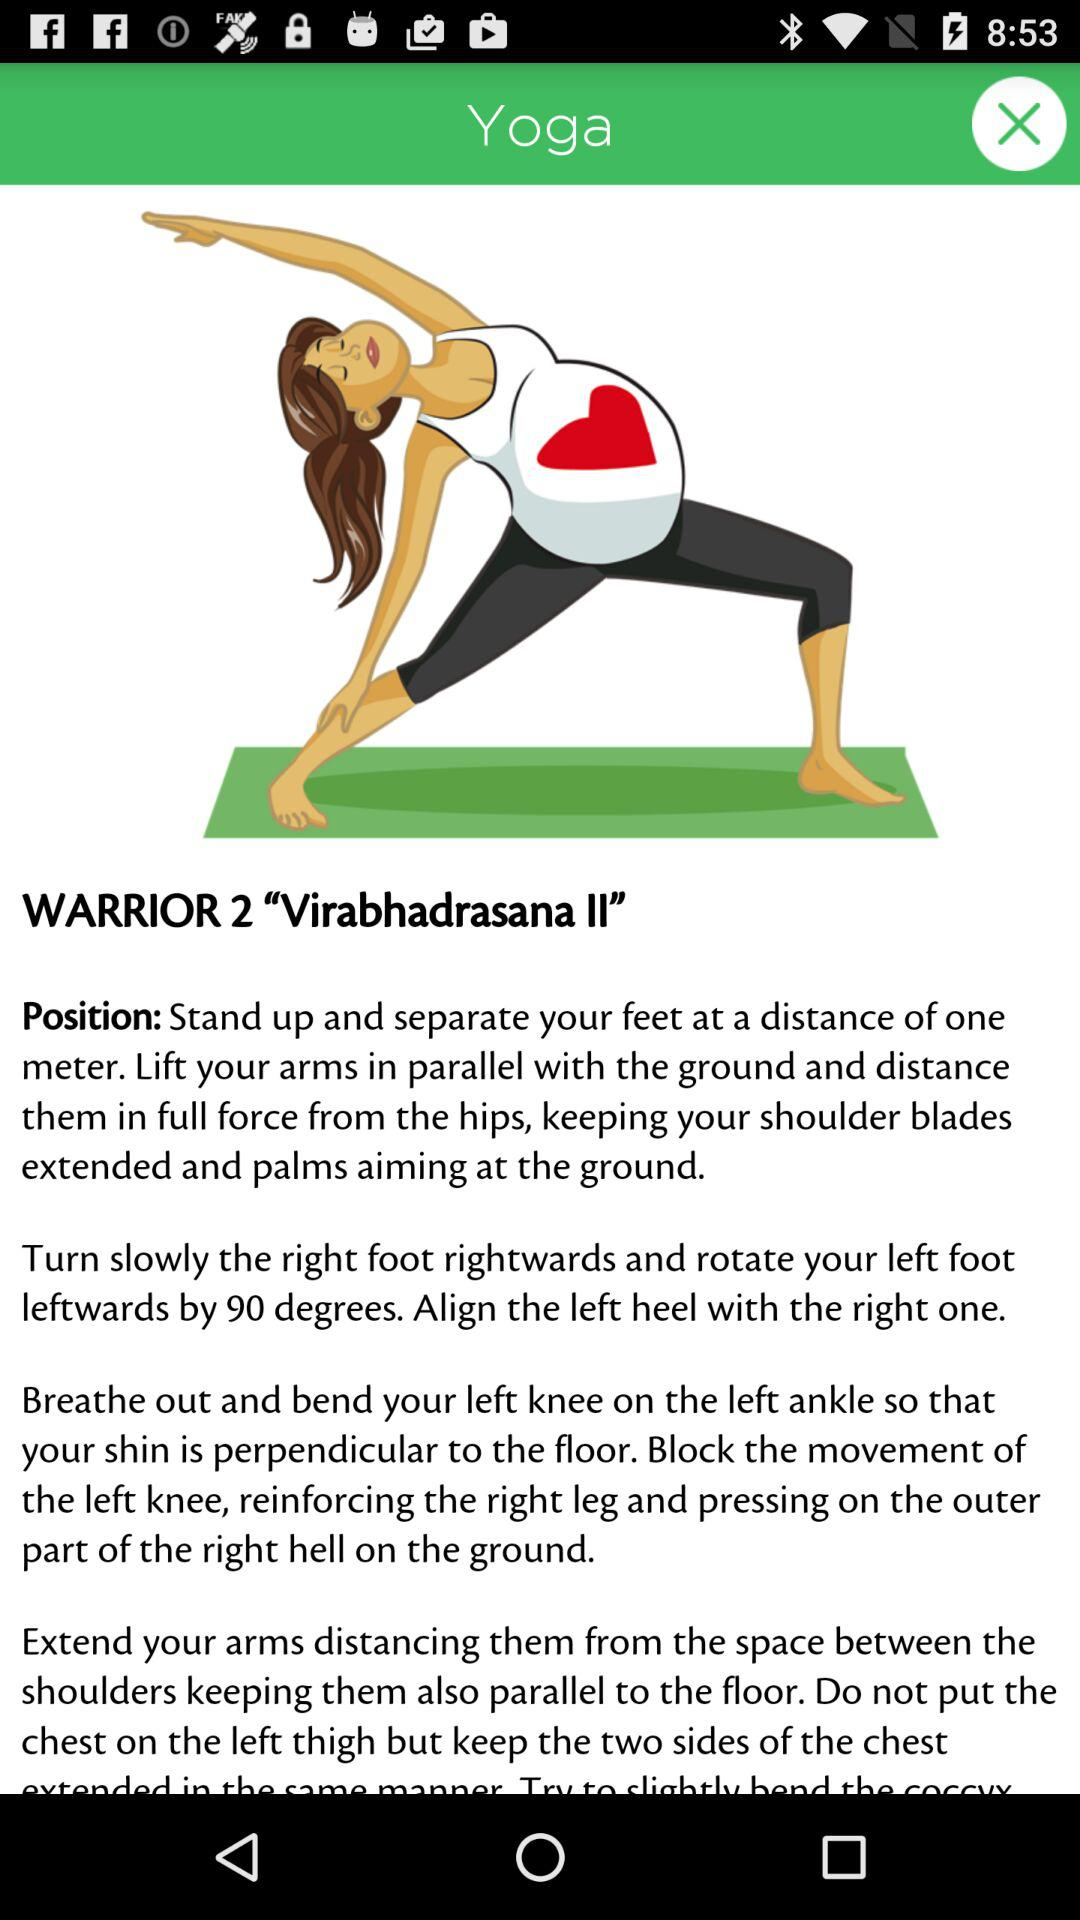What is Virabhadrasana?
When the provided information is insufficient, respond with <no answer>. <no answer> 